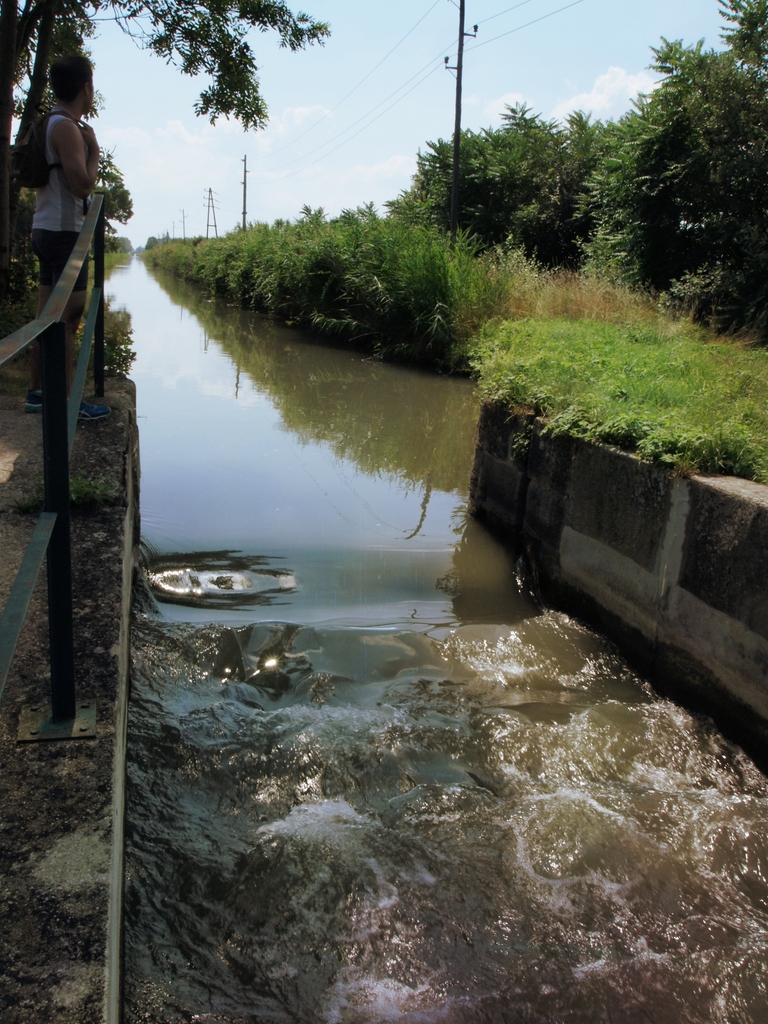What can be seen in the sky in the image? The sky with clouds is visible in the image. What type of natural elements are present in the image? There are trees in the image. What man-made structures can be seen in the image? Electric poles and a bridge are present in the image. What utility infrastructure is visible in the image? Electric cables are visible in the image. What is the person in the image doing? There is a person standing on a bridge in the image. What type of water feature is present in the image? Running water is present in the image. Can you tell me how many queens are playing a lock battle in the image? There is no queen or lock battle present in the image. What type of creature is shown participating in the battle on the bridge? There is no creature or battle present in the image; only a person standing on a bridge can be seen. 